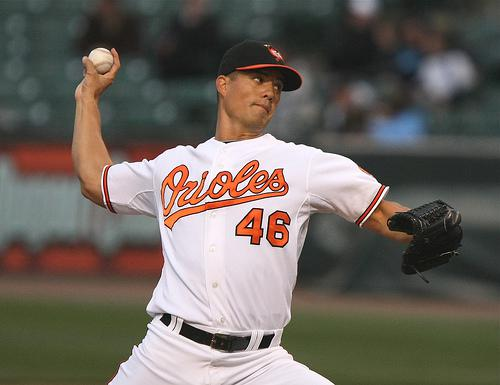Question: what sport is depicted?
Choices:
A. Football.
B. Baseball.
C. Soccer.
D. Cricket.
Answer with the letter. Answer: B Question: what team is in the field?
Choices:
A. The Orioles.
B. The Braves.
C. The Indians.
D. The Yankees.
Answer with the letter. Answer: A Question: what position does number 46 play?
Choices:
A. Pitcher.
B. Shortstop.
C. 2nd baseman.
D. Catcher.
Answer with the letter. Answer: A Question: how are the pitcher's arms positioned?
Choices:
A. Down.
B. Up.
C. Holding the ball.
D. Left arm is in front of his body and the right arm is raised.
Answer with the letter. Answer: D Question: where was this picture taken?
Choices:
A. A yankee stadium.
B. In new york.
C. In queens.
D. At a baseball field.
Answer with the letter. Answer: D Question: where does the number 46 appear?
Choices:
A. On the pitcher's shirt.
B. On the back of his shirt.
C. On his hat.
D. On his shoes.
Answer with the letter. Answer: A 